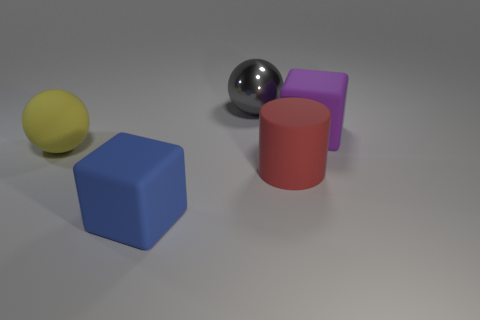Add 3 small red cylinders. How many objects exist? 8 Subtract all balls. How many objects are left? 3 Subtract 0 brown cylinders. How many objects are left? 5 Subtract all red matte spheres. Subtract all large red rubber objects. How many objects are left? 4 Add 1 yellow matte things. How many yellow matte things are left? 2 Add 1 large metal cylinders. How many large metal cylinders exist? 1 